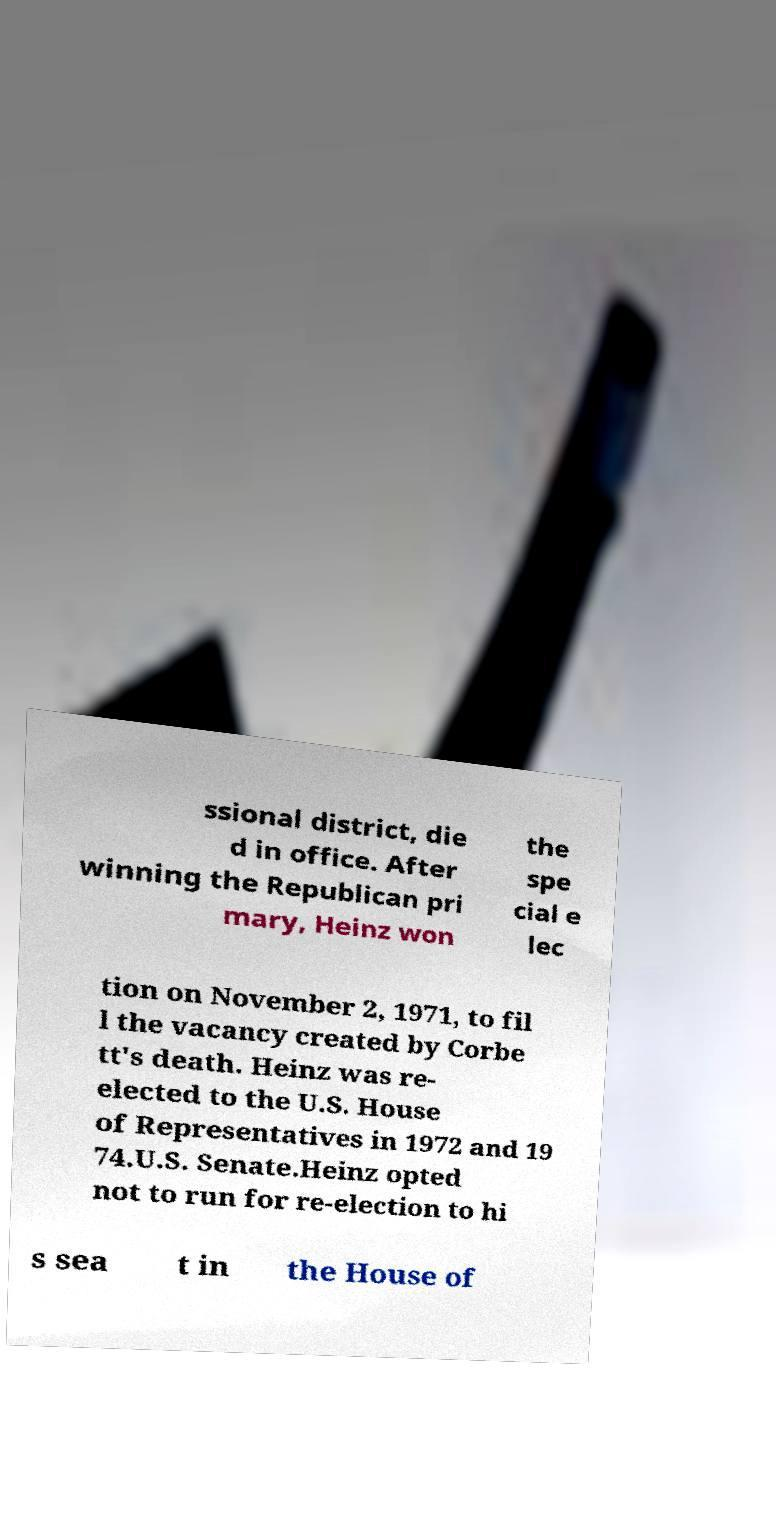Please read and relay the text visible in this image. What does it say? ssional district, die d in office. After winning the Republican pri mary, Heinz won the spe cial e lec tion on November 2, 1971, to fil l the vacancy created by Corbe tt's death. Heinz was re- elected to the U.S. House of Representatives in 1972 and 19 74.U.S. Senate.Heinz opted not to run for re-election to hi s sea t in the House of 